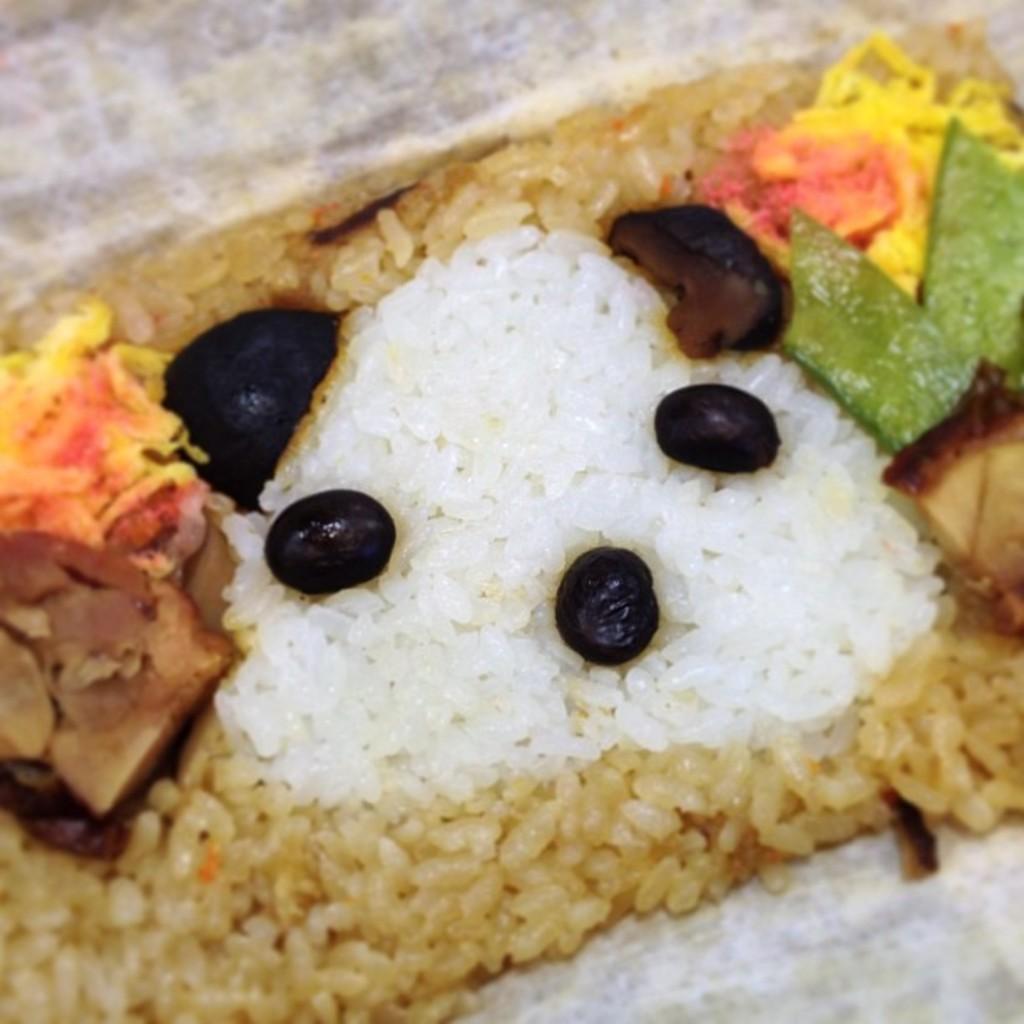Please provide a concise description of this image. In the middle of this image, there there are fruits, rice and other food items placed on a plate. And the background is in gray and white color combination. 